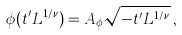Convert formula to latex. <formula><loc_0><loc_0><loc_500><loc_500>\phi ( t ^ { \prime } L ^ { 1 / \nu } ) = A _ { \phi } \sqrt { - t ^ { \prime } L ^ { 1 / \nu } } \, ,</formula> 